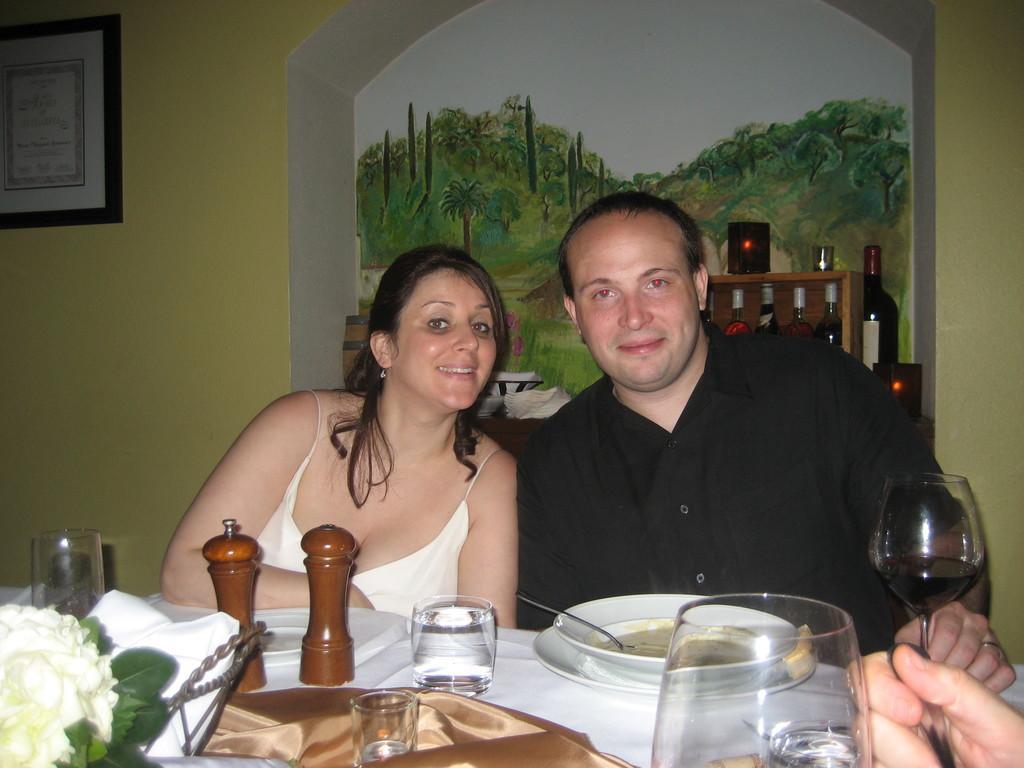In one or two sentences, can you explain what this image depicts? These two persons are sitting. On the background we can see wall,frame. There is a table. On the table we can see glass,plate,bowl,spoon,food,cloth,flower,paper and things. 